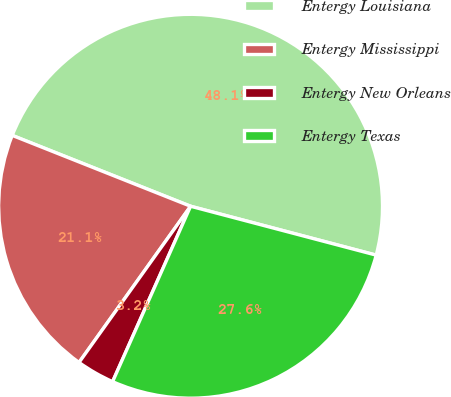Convert chart to OTSL. <chart><loc_0><loc_0><loc_500><loc_500><pie_chart><fcel>Entergy Louisiana<fcel>Entergy Mississippi<fcel>Entergy New Orleans<fcel>Entergy Texas<nl><fcel>48.08%<fcel>21.15%<fcel>3.21%<fcel>27.56%<nl></chart> 